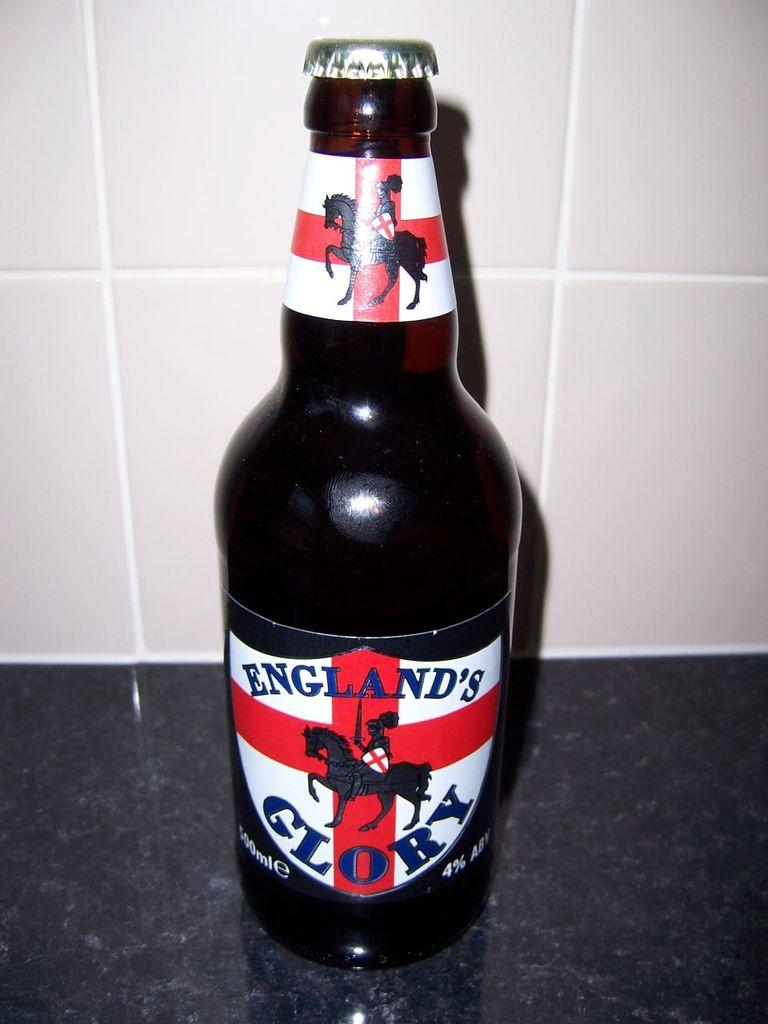<image>
Share a concise interpretation of the image provided. A bottle of England's Glory beer has a knight and horse on the label. 